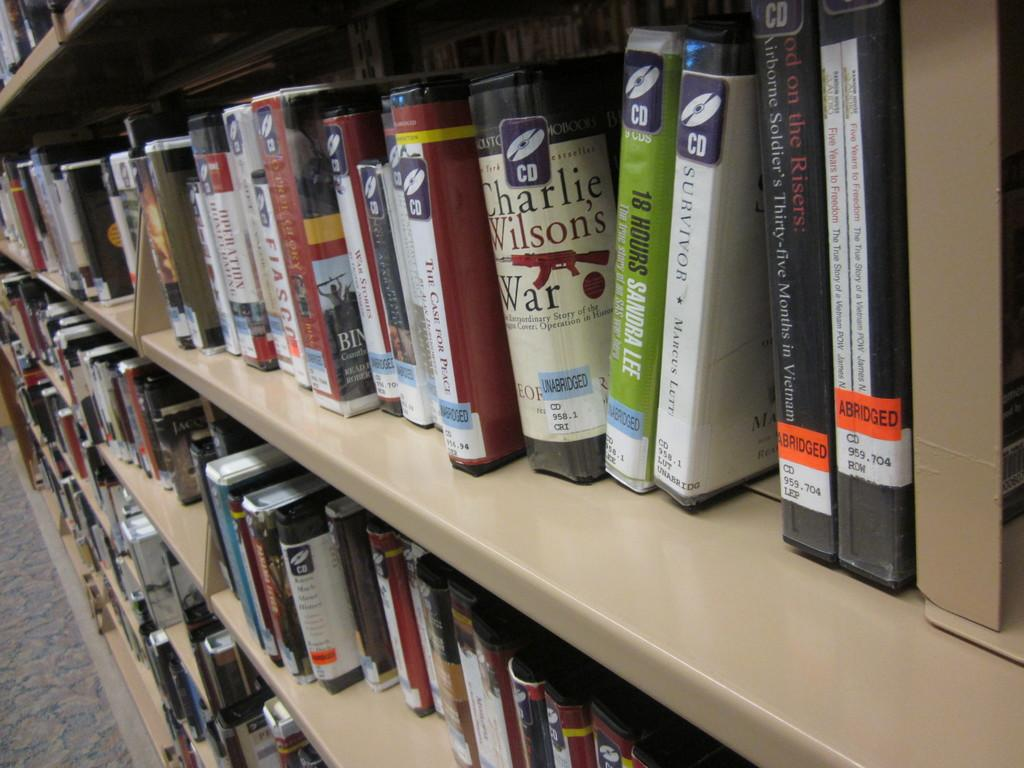<image>
Share a concise interpretation of the image provided. Bunch of books on a shelf with a green one that says 18 hours. 